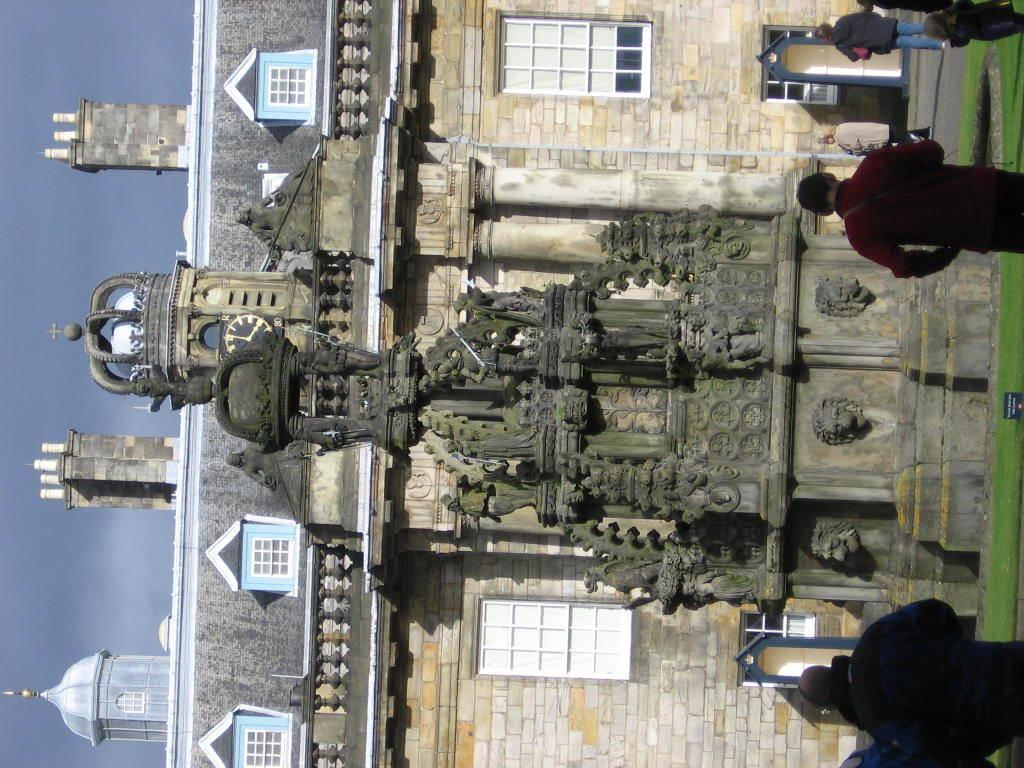What type of structures can be seen in the image? There are buildings in the image. Can you describe the people in the image? There is a group of people in the image. What type of natural environment is visible in the image? There is grass visible in the image. What book is the porter holding in the image? There is no porter or book present in the image. Where is the spot where the group of people is standing in the image? The group of people is not standing in a specific spot; they are simply visible in the image. 